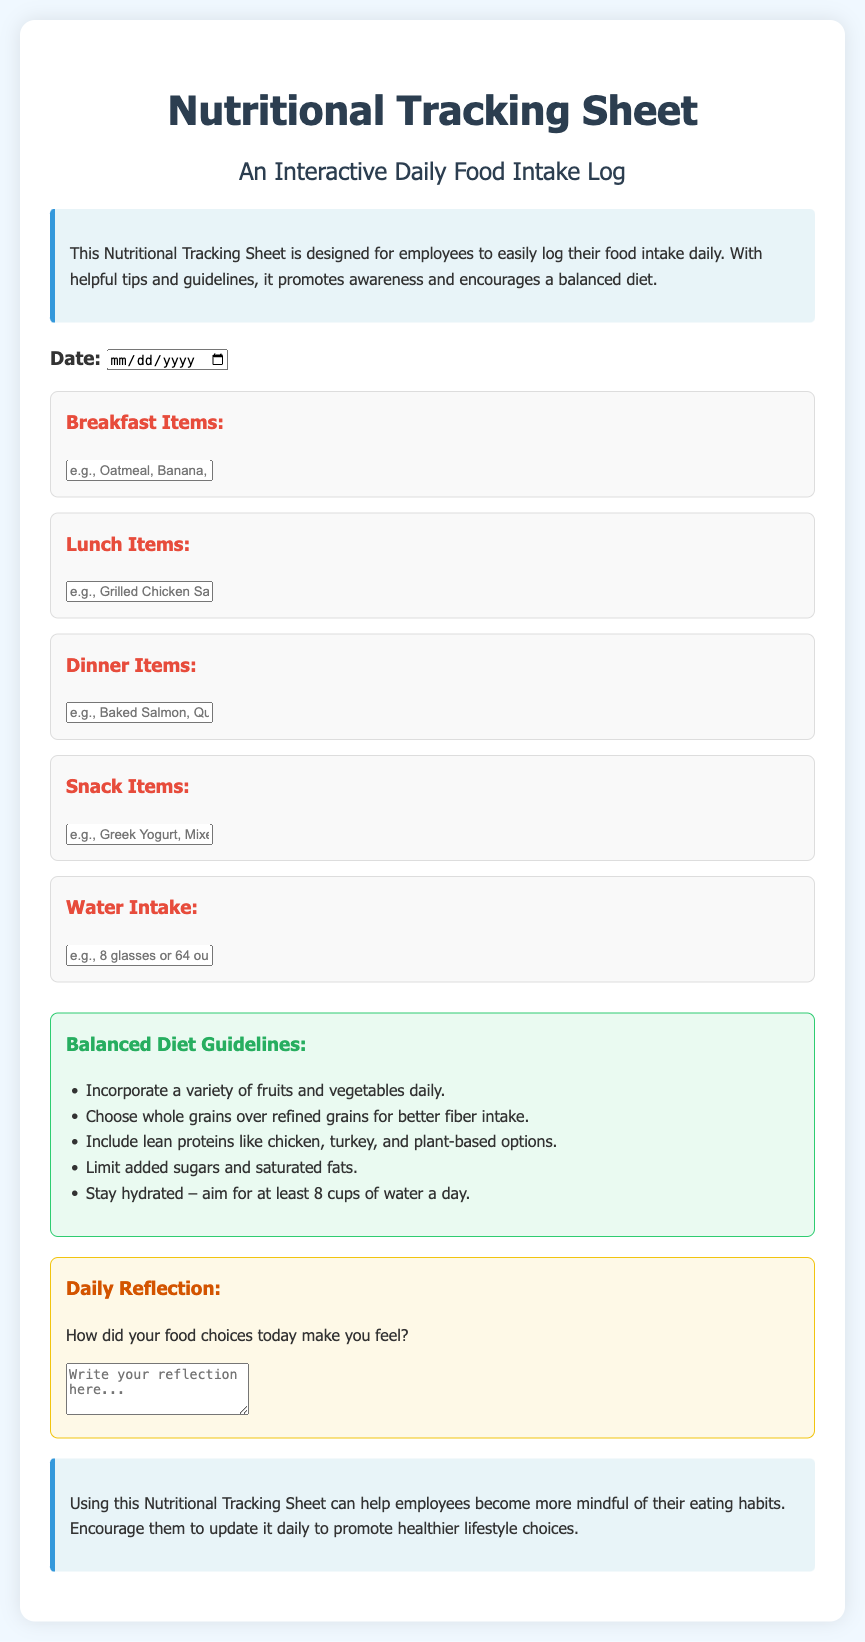What is the main purpose of the Nutritional Tracking Sheet? The document states that the Nutritional Tracking Sheet is designed for employees to easily log their food intake daily and promote awareness of a balanced diet.
Answer: log their food intake daily How many meal types are included in the tracking section? The tracking section includes four meal types: Breakfast, Lunch, Dinner, and Snacks.
Answer: four What is the recommended daily water intake mentioned? The guidelines suggest aiming for at least 8 cups of water a day.
Answer: 8 cups What color is the background of the introduction section? The introduction section has a background color of light blue.
Answer: light blue Which type of foods should be limited according to the guidelines? The guidelines advise to limit added sugars and saturated fats.
Answer: added sugars and saturated fats What is one reflection prompt provided in the document? The daily reflection prompt asks, "How did your food choices today make you feel?"
Answer: How did your food choices today make you feel? What feature makes the document interactive? The interactive feature includes input fields where users can log meal items and water intake.
Answer: input fields Which meal log section is mentioned first? The first meal log section mentioned is for Breakfast items.
Answer: Breakfast items 